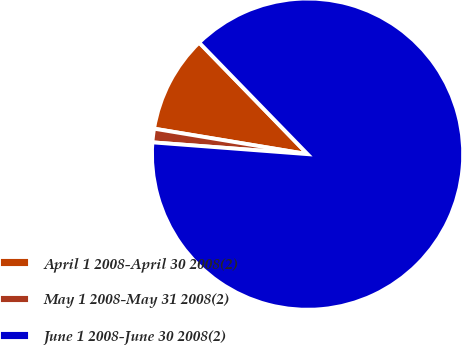Convert chart. <chart><loc_0><loc_0><loc_500><loc_500><pie_chart><fcel>April 1 2008-April 30 2008(2)<fcel>May 1 2008-May 31 2008(2)<fcel>June 1 2008-June 30 2008(2)<nl><fcel>10.11%<fcel>1.41%<fcel>88.48%<nl></chart> 